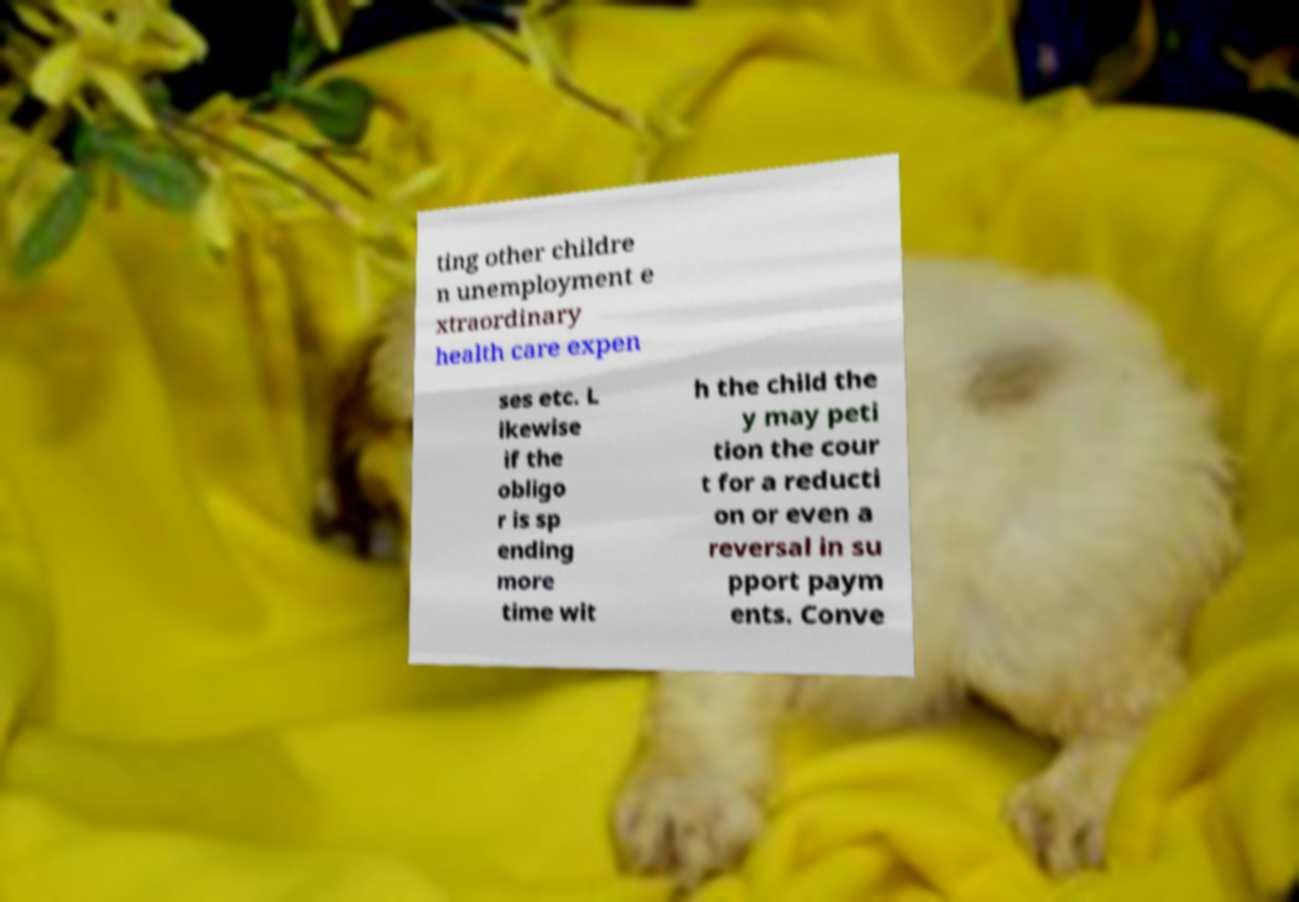I need the written content from this picture converted into text. Can you do that? ting other childre n unemployment e xtraordinary health care expen ses etc. L ikewise if the obligo r is sp ending more time wit h the child the y may peti tion the cour t for a reducti on or even a reversal in su pport paym ents. Conve 